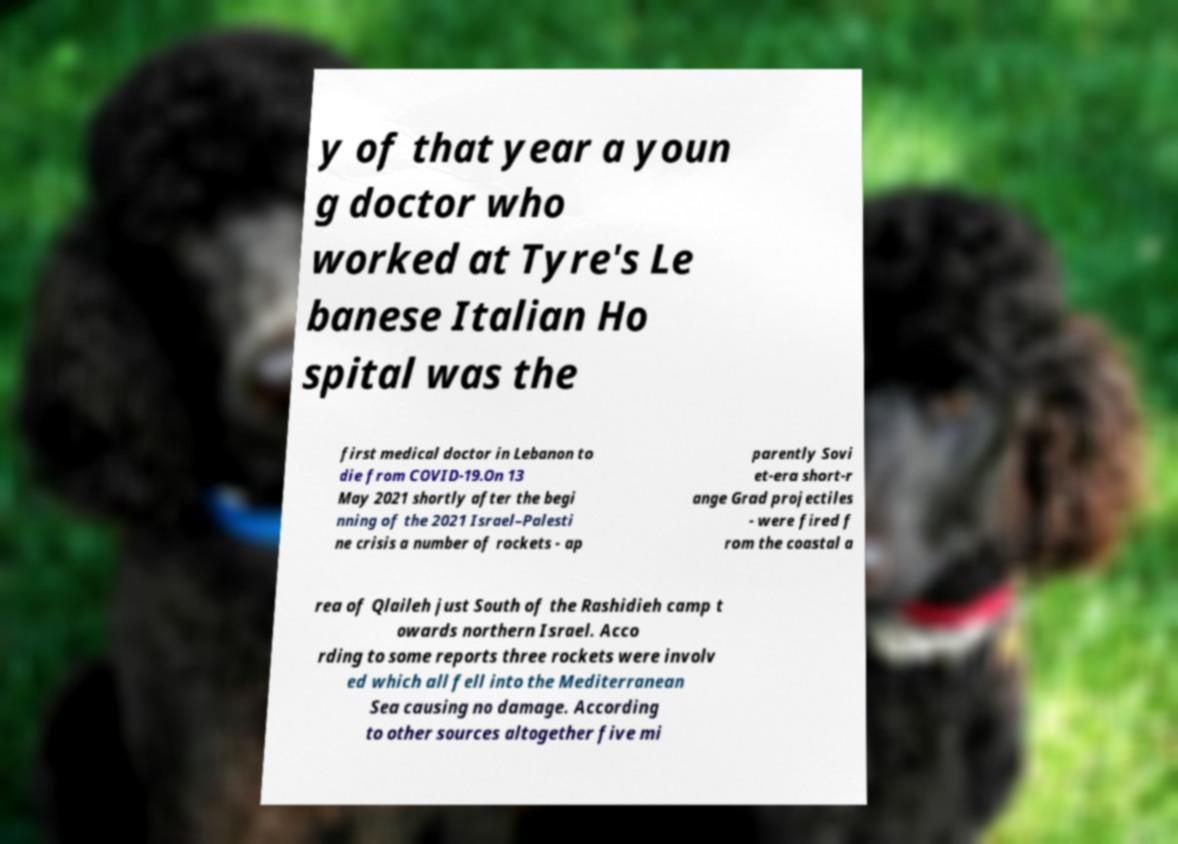Please identify and transcribe the text found in this image. y of that year a youn g doctor who worked at Tyre's Le banese Italian Ho spital was the first medical doctor in Lebanon to die from COVID-19.On 13 May 2021 shortly after the begi nning of the 2021 Israel–Palesti ne crisis a number of rockets - ap parently Sovi et-era short-r ange Grad projectiles - were fired f rom the coastal a rea of Qlaileh just South of the Rashidieh camp t owards northern Israel. Acco rding to some reports three rockets were involv ed which all fell into the Mediterranean Sea causing no damage. According to other sources altogether five mi 